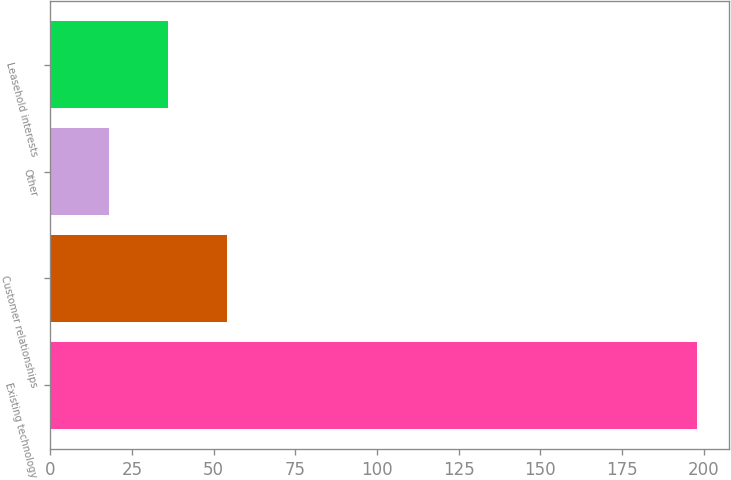Convert chart. <chart><loc_0><loc_0><loc_500><loc_500><bar_chart><fcel>Existing technology<fcel>Customer relationships<fcel>Other<fcel>Leasehold interests<nl><fcel>198<fcel>54<fcel>18<fcel>36<nl></chart> 